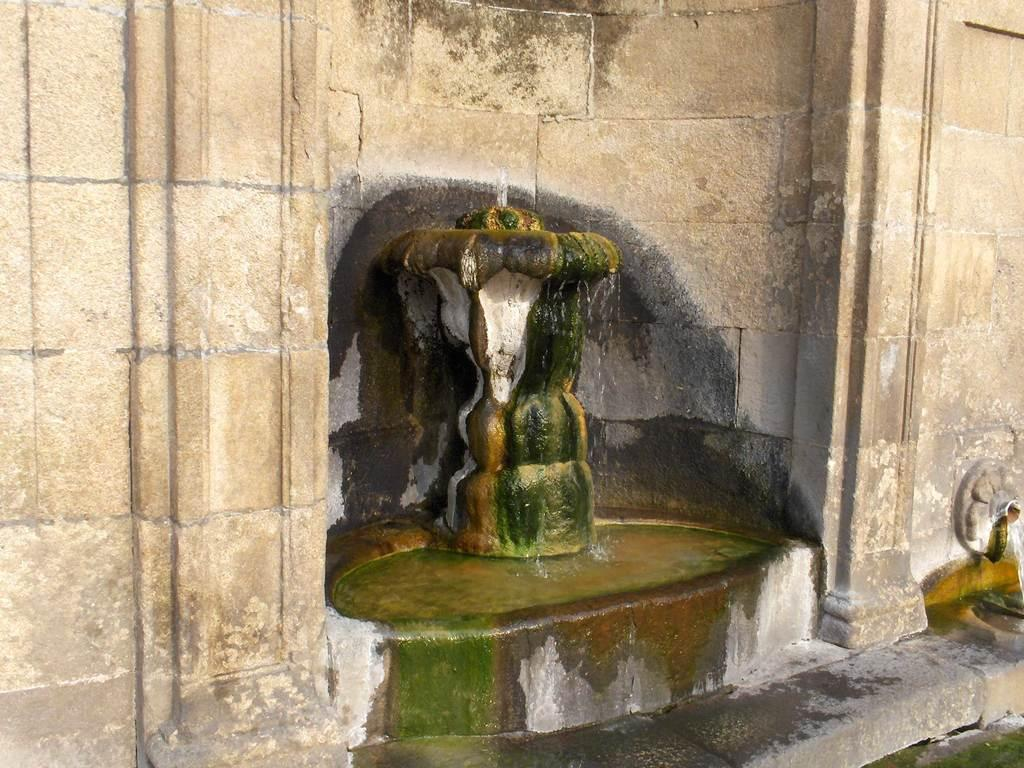What is the main subject in the middle of the image? There is a statue in the middle of the image. What can be seen in the background of the image? There is a wall in the background of the image. How does the statue depict the concept of death in the image? The image does not depict the concept of death, nor does it provide any context for the statue's meaning or symbolism. 